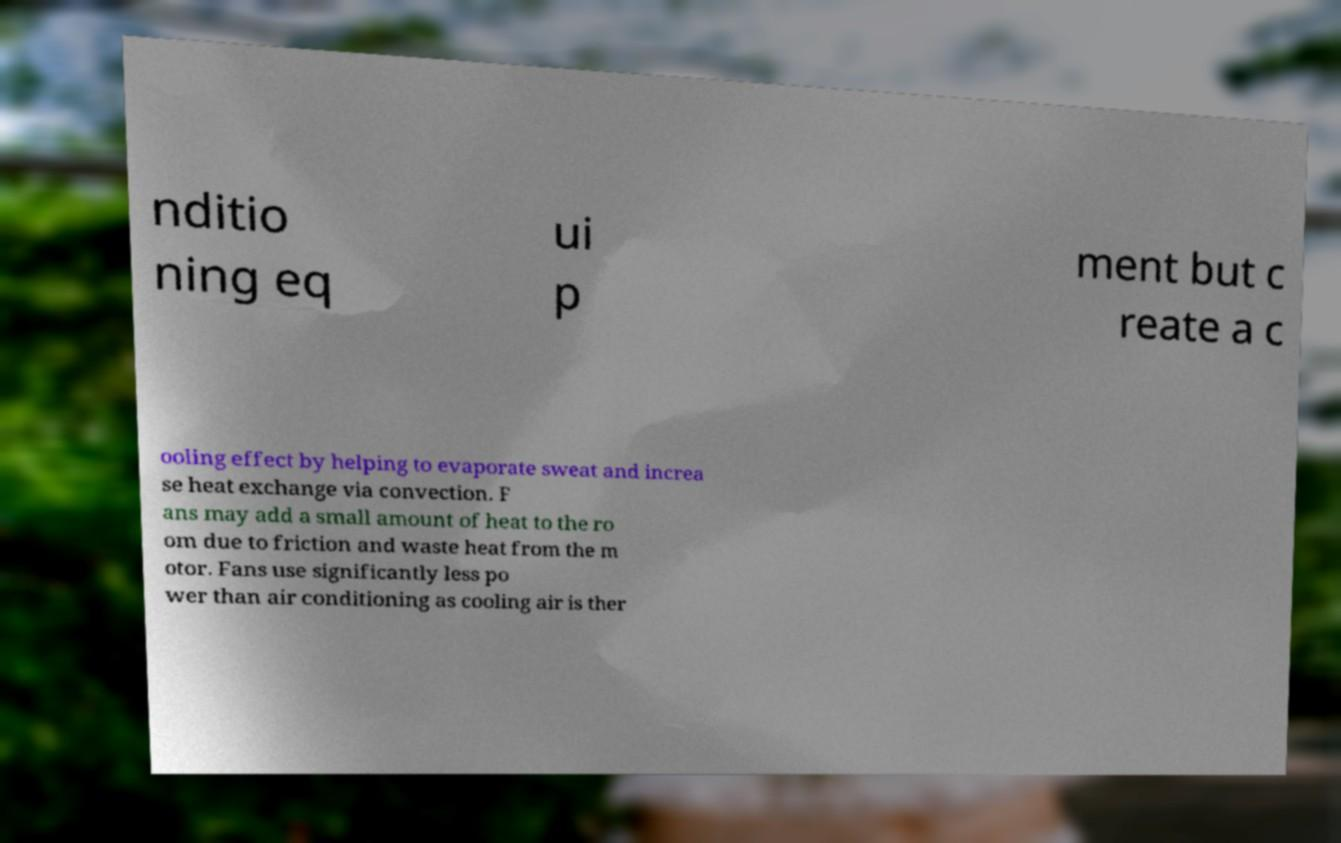There's text embedded in this image that I need extracted. Can you transcribe it verbatim? nditio ning eq ui p ment but c reate a c ooling effect by helping to evaporate sweat and increa se heat exchange via convection. F ans may add a small amount of heat to the ro om due to friction and waste heat from the m otor. Fans use significantly less po wer than air conditioning as cooling air is ther 